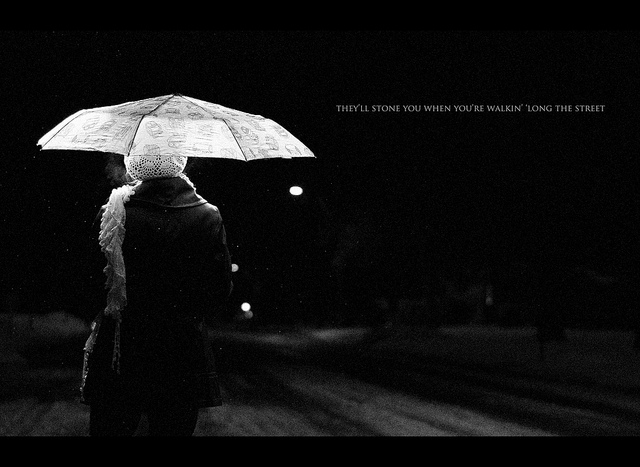<image>Who said the quote that is written in the background of the picture? It is unknown who said the quote written in the background. It could be anyone from Andrew Jackson, Bob Dylan, MLK, to John F. Kennedy. Is this photo manipulated? It is ambiguous if the photo is manipulated. Who said the quote that is written in the background of the picture? I am not sure who said the quote that is written in the background of the picture. It can be Andrew Jackson, Bob Dylan, MLK, John F Kennedy or someone else. Is this photo manipulated? I don't know if this photo is manipulated. It can be either manipulated or not. 